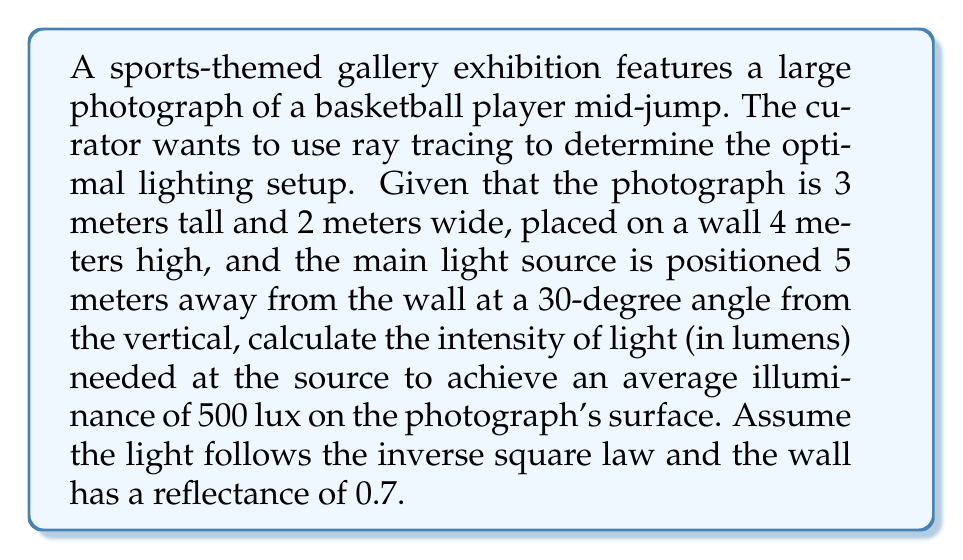Can you answer this question? To solve this problem, we'll follow these steps:

1) First, calculate the distance from the light source to the center of the photograph:
   Let's assume the photograph is centered on the wall.
   Height of photo center = 4m / 2 = 2m
   Distance from light to wall = 5m
   Angle from vertical = 30°
   
   Using trigonometry:
   $$d = \sqrt{5^2 + 2^2 - 2(5)(2)\cos(90°+30°)} = 5.24m$$

2) Calculate the area of the photograph:
   $$A = 3m * 2m = 6m^2$$

3) Use the inverse square law to relate illuminance (E) to luminous intensity (I):
   $$E = \frac{I}{d^2}$$
   
   Rearranging for I:
   $$I = E * d^2$$

4) Account for the angle of incidence:
   The effective illuminance is reduced by $\cos(30°)$ due to the angle.
   
5) Account for wall reflectance:
   The required illuminance is increased by a factor of $\frac{1}{0.7}$ due to absorption.

6) Putting it all together:
   $$I = \frac{500 \text{ lux}}{0.7 * \cos(30°)} * (5.24m)^2$$
   $$I = \frac{500 * 5.24^2}{0.7 * 0.866} = 21,834 \text{ lumens}$$
Answer: 21,834 lumens 